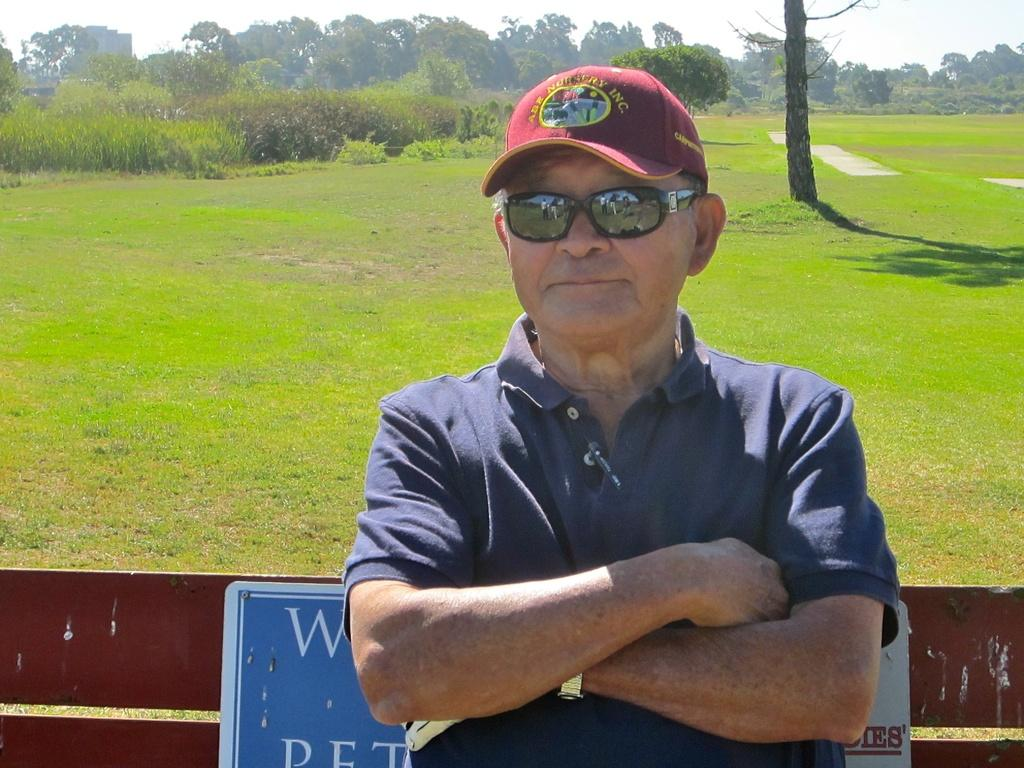What is the person in the image doing? The person is sitting on a bench in the image. What can be seen in the background of the image? There is grass, trees, plants, and the sky visible in the background of the image. What type of bubble can be seen floating near the person on the bench? There is no bubble present in the image. What kind of plantation is visible in the background of the image? There is no plantation present in the image; it features grass, trees, and plants in the background. 